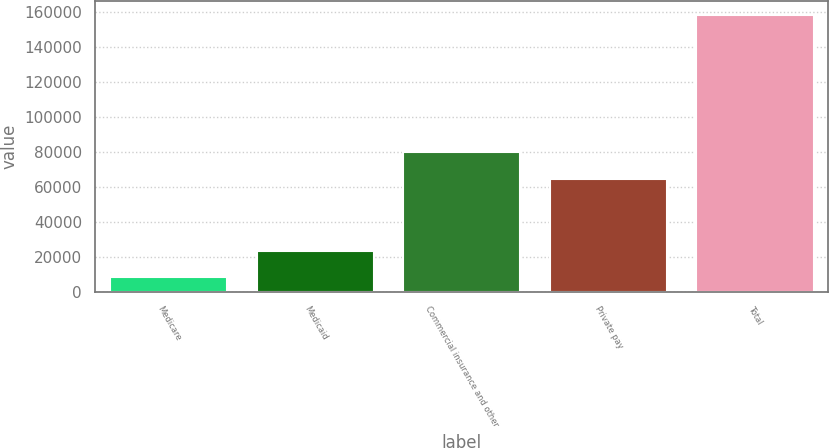Convert chart to OTSL. <chart><loc_0><loc_0><loc_500><loc_500><bar_chart><fcel>Medicare<fcel>Medicaid<fcel>Commercial insurance and other<fcel>Private pay<fcel>Total<nl><fcel>8240<fcel>23276.5<fcel>79743.5<fcel>64707<fcel>158605<nl></chart> 